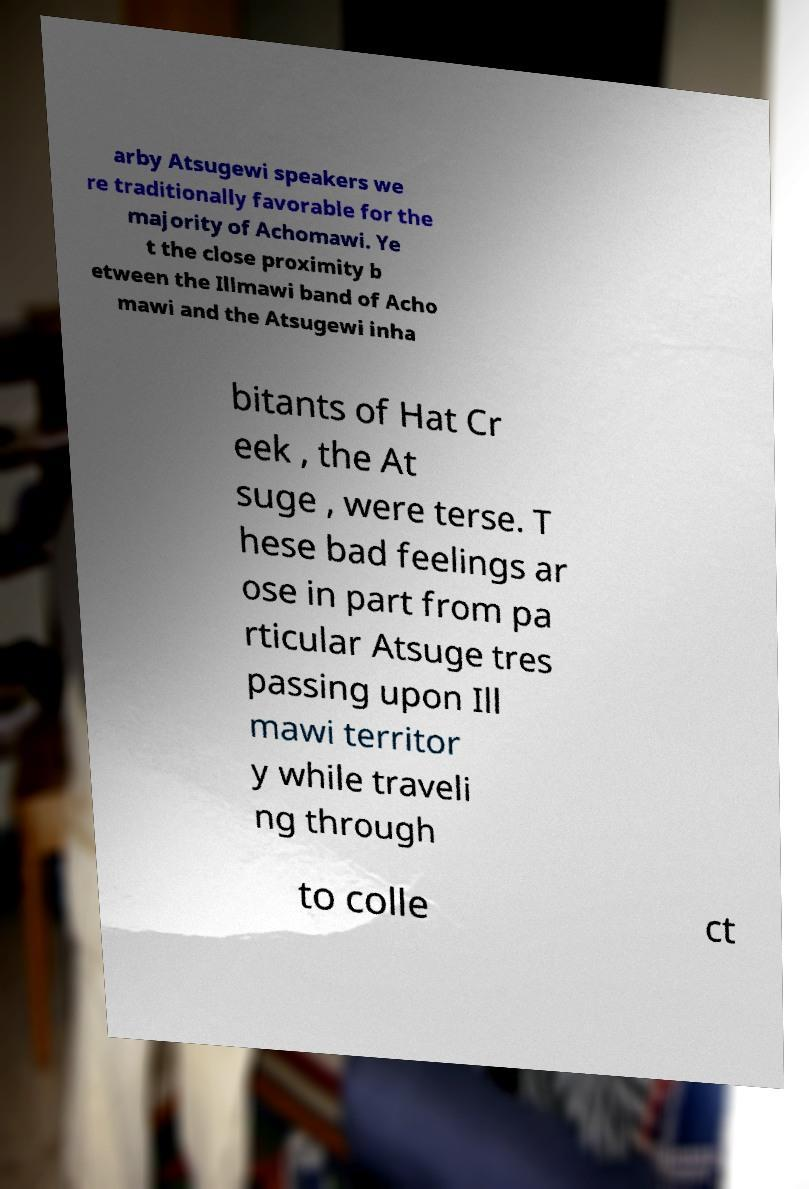Can you accurately transcribe the text from the provided image for me? arby Atsugewi speakers we re traditionally favorable for the majority of Achomawi. Ye t the close proximity b etween the Illmawi band of Acho mawi and the Atsugewi inha bitants of Hat Cr eek , the At suge , were terse. T hese bad feelings ar ose in part from pa rticular Atsuge tres passing upon Ill mawi territor y while traveli ng through to colle ct 